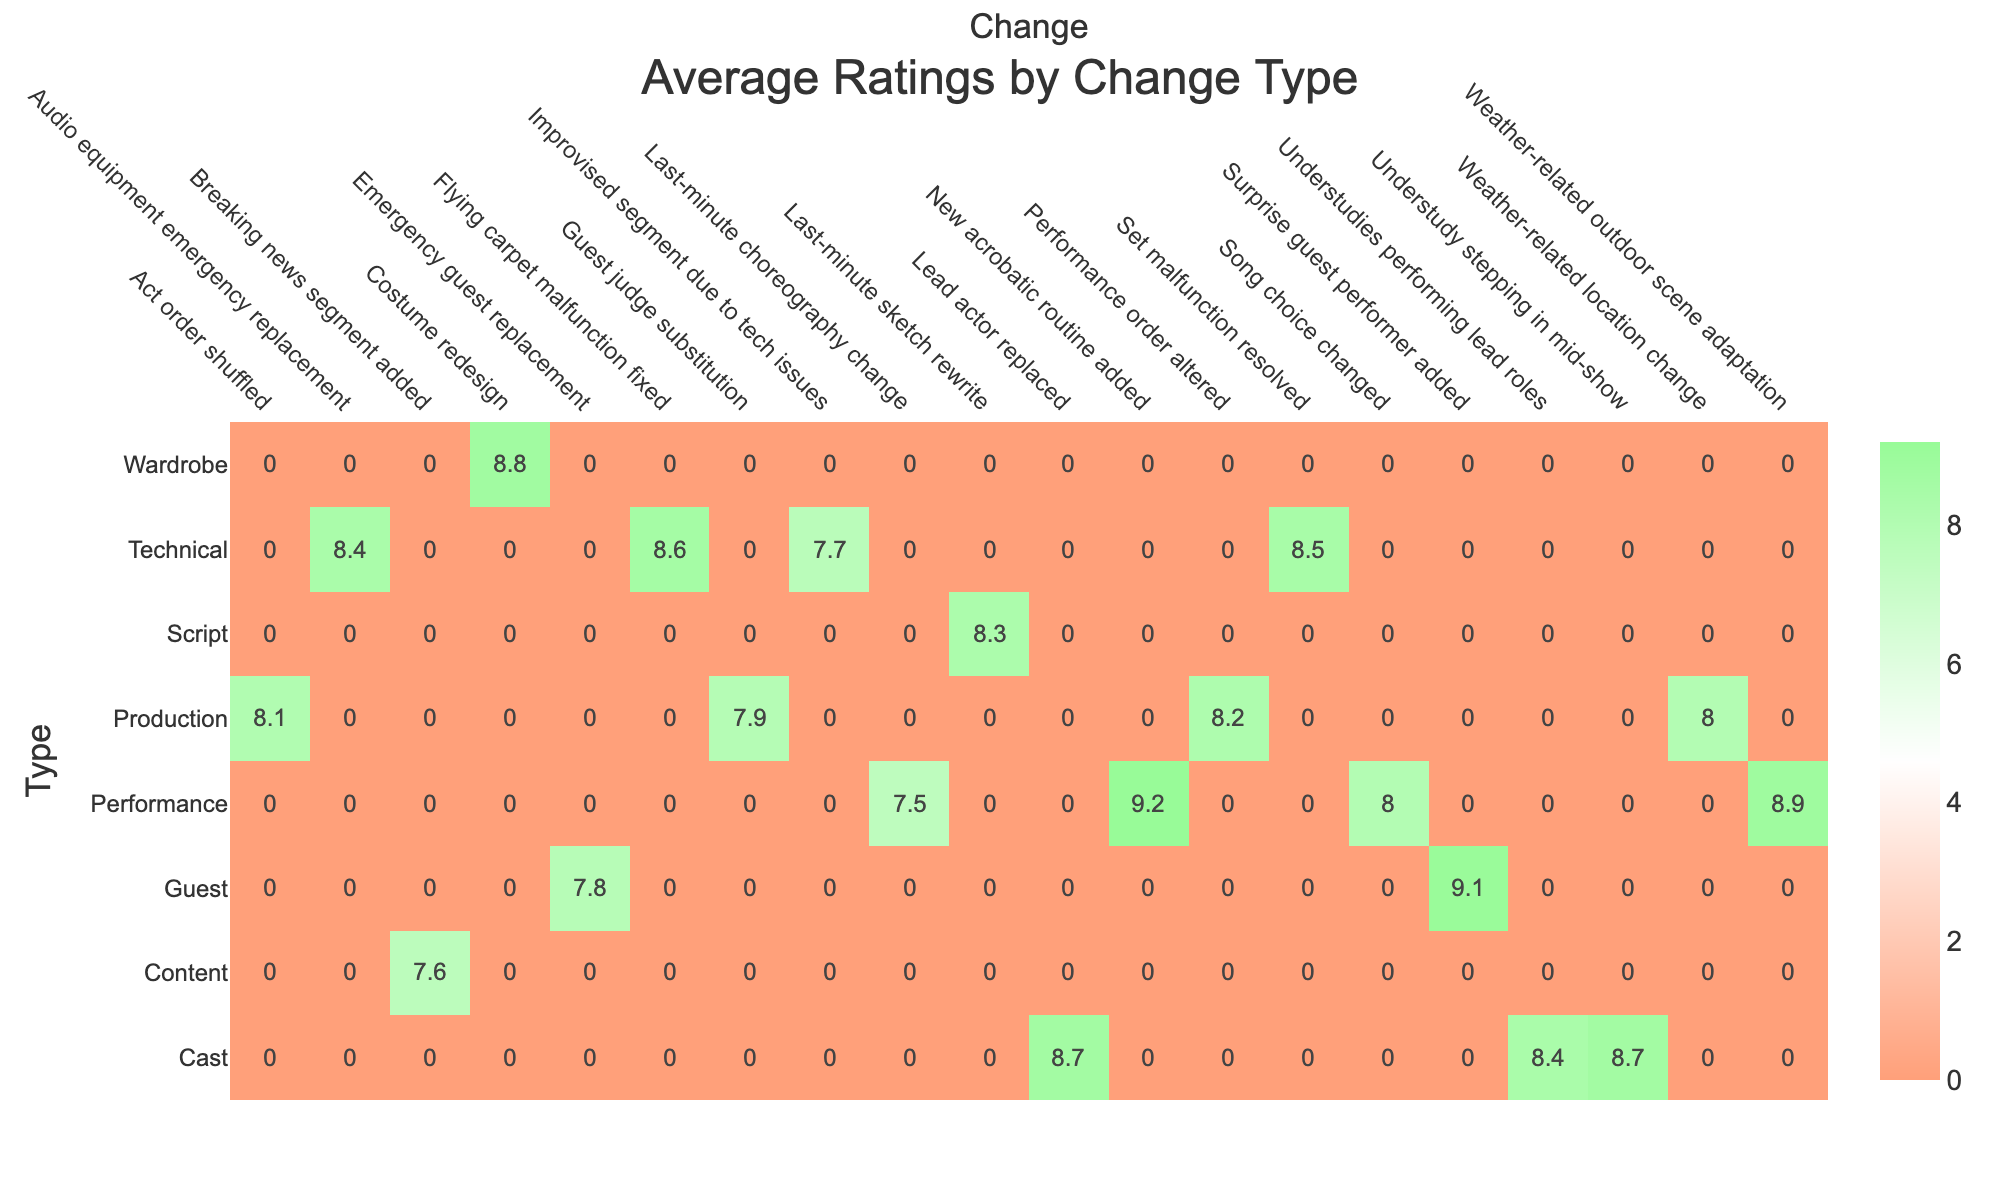What is the average rating for last-minute technical changes? To find the average rating for technical changes, we first identify all instances where the type is 'Technical'. These entries are 'Set malfunction resolved' (8.5), 'Improvised segment due to tech issues' (7.7), 'Flying carpet malfunction fixed' (8.6), and 'Audio equipment emergency replacement' (8.4). Adding these ratings together gives 8.5 + 7.7 + 8.6 + 8.4 = 33.2. There are four data points, so we divide by 4 to find the average: 33.2 / 4 = 8.3.
Answer: 8.3 Which change had the highest audience satisfaction? We need to look for the maximum value in the Audience Satisfaction column. By reviewing the entries, we see that the change 'Surprise guest performer added' has the highest satisfaction at 96%.
Answer: 96% Was there a last-minute change that impacted the audience satisfaction positively? Yes, the data shows 'New acrobatic routine added' improved audience satisfaction to 95%, indicating that the last-minute change had a positive effect.
Answer: Yes How many millions of viewers were there for shows with a cast change? The shows with cast changes are 'Lead actor replaced' (2.3 million), 'Understudies performing lead roles' (1.7 million), and 'Understudy stepping in mid-show' (1.3 million). Adding these viewers gives 2.3 + 1.7 + 1.3 = 5.3 million.
Answer: 5.3 million What is the difference in ratings between performance changes and production changes? First, we note the average ratings for both change types. The ratings for performance changes are from 'New acrobatic routine added' (9.2), 'Act order shuffled' (8.1), 'Song choice changed' (8.0), 'Weather-related outdoor scene adaptation' (8.9), 'Last-minute choreography change' (7.5). Adding these yields 41.7, and dividing by 5 gives an average of 8.34. The ratings for production changes are from 'Guest judge substitution' (7.9), 'Act order shuffled' (8.1), 'Emergency guest replacement' (7.8), 'Weather-related location change' (8.0), 'Performance order altered' (8.2). This totals 40.0, and thus the average is 40.0 / 5 = 8.0. The difference is 8.34 - 8.0 = 0.34.
Answer: 0.34 Did any show experience a drop in audience satisfaction due to last-minute changes? Yes, 'Live with Kelly and Mark' had a breaking news segment added and resulted in an audience satisfaction of 84%, which is noticeably lower than others in the data.
Answer: Yes 